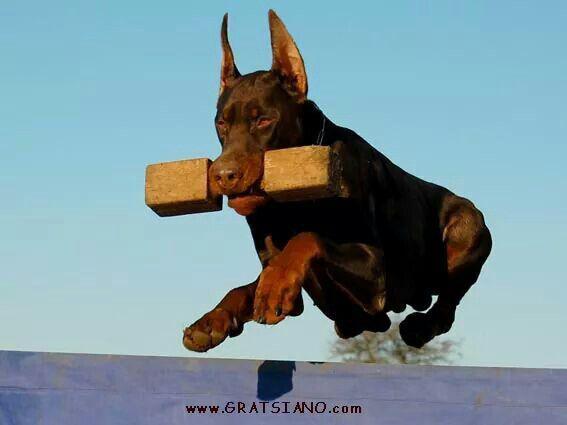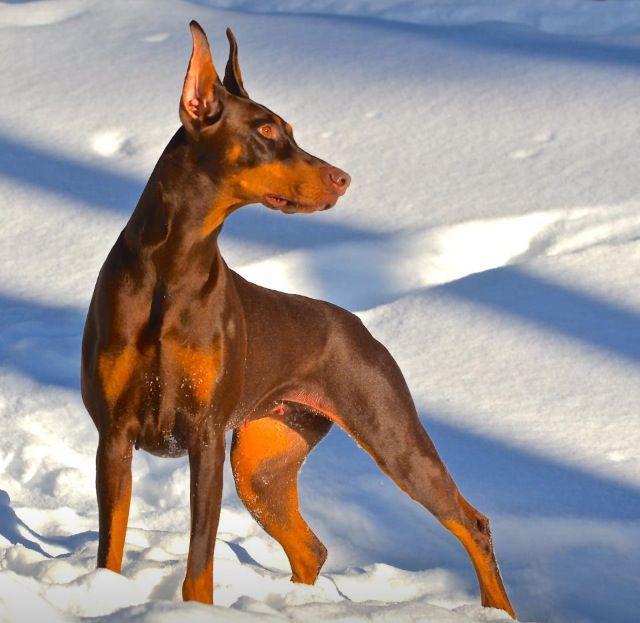The first image is the image on the left, the second image is the image on the right. Evaluate the accuracy of this statement regarding the images: "In one of the images, the dogs are wearing things on their paws.". Is it true? Answer yes or no. No. The first image is the image on the left, the second image is the image on the right. Analyze the images presented: Is the assertion "In one of the images, a doberman is holding an object in its mouth." valid? Answer yes or no. Yes. 